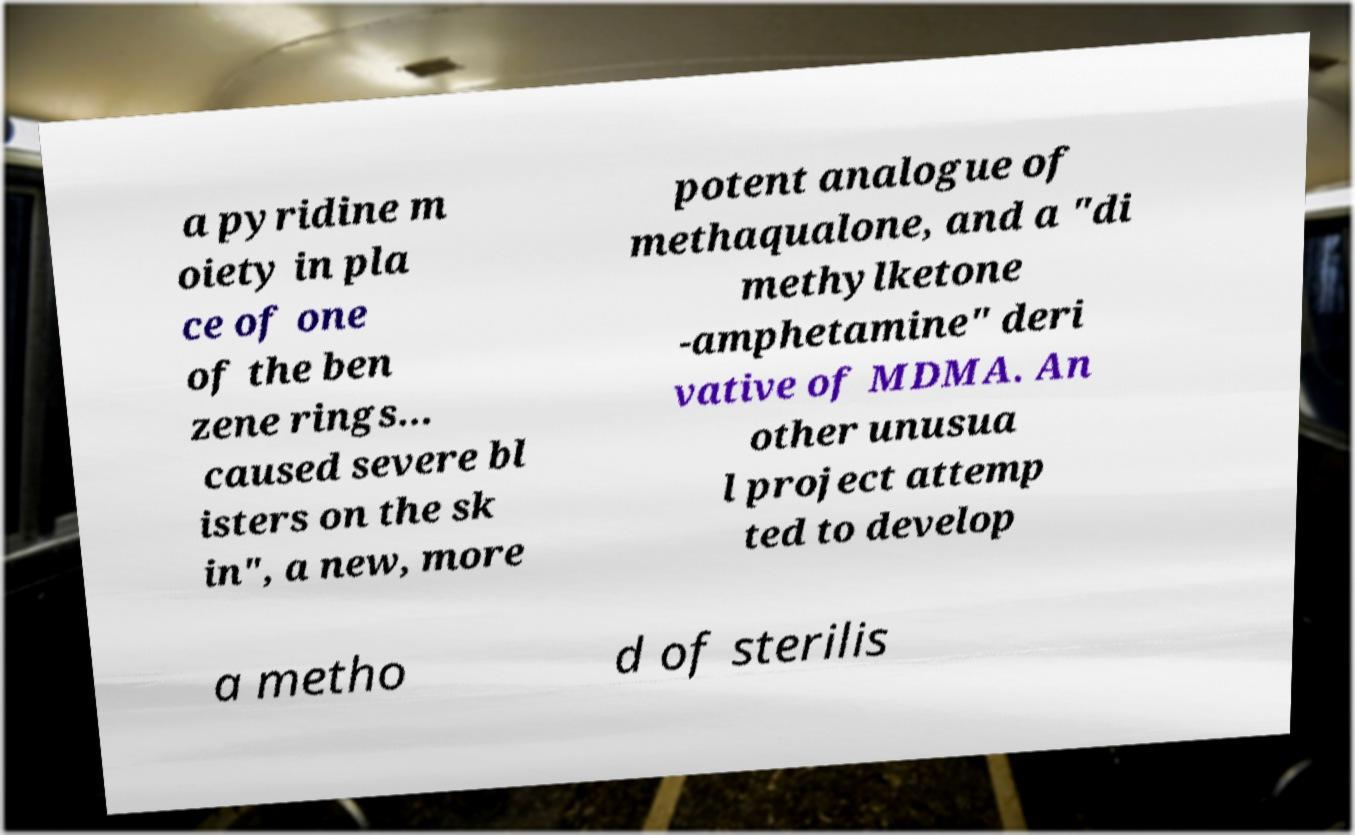Please identify and transcribe the text found in this image. a pyridine m oiety in pla ce of one of the ben zene rings... caused severe bl isters on the sk in", a new, more potent analogue of methaqualone, and a "di methylketone -amphetamine" deri vative of MDMA. An other unusua l project attemp ted to develop a metho d of sterilis 